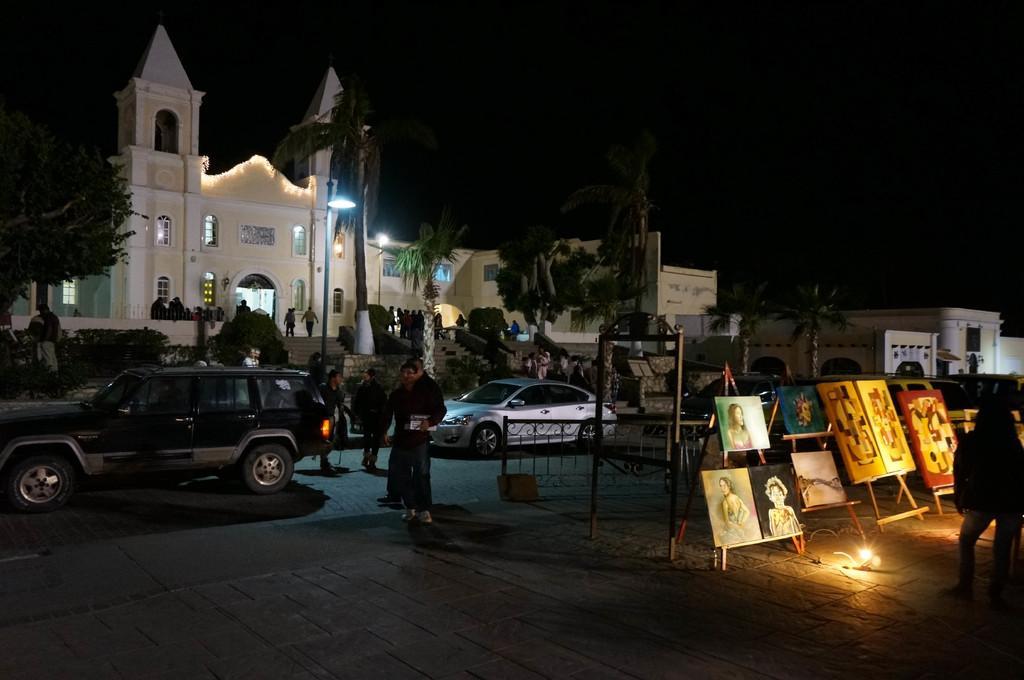Please provide a concise description of this image. In the picture we can see a path with tiles and on it we can see some paintings are placed on the stands and behind it we can see a railing and near it we can see some people are standing and we can see some cars and behind it we can see a building and some people are walking through it and besides we can see some other buildings and trees near it. 